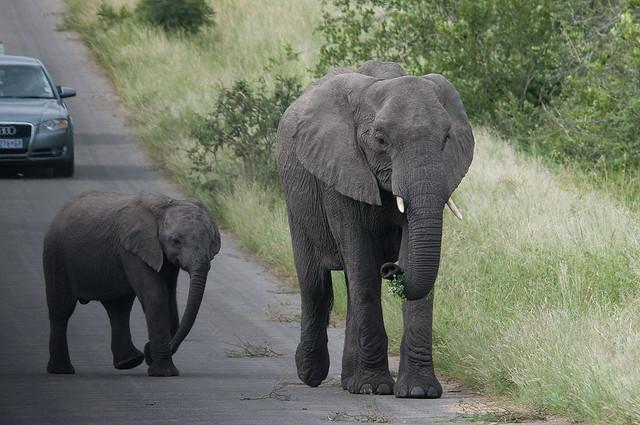What movie character fits in with these animals? Please explain your reasoning. dumbo. The character is dumbo. 